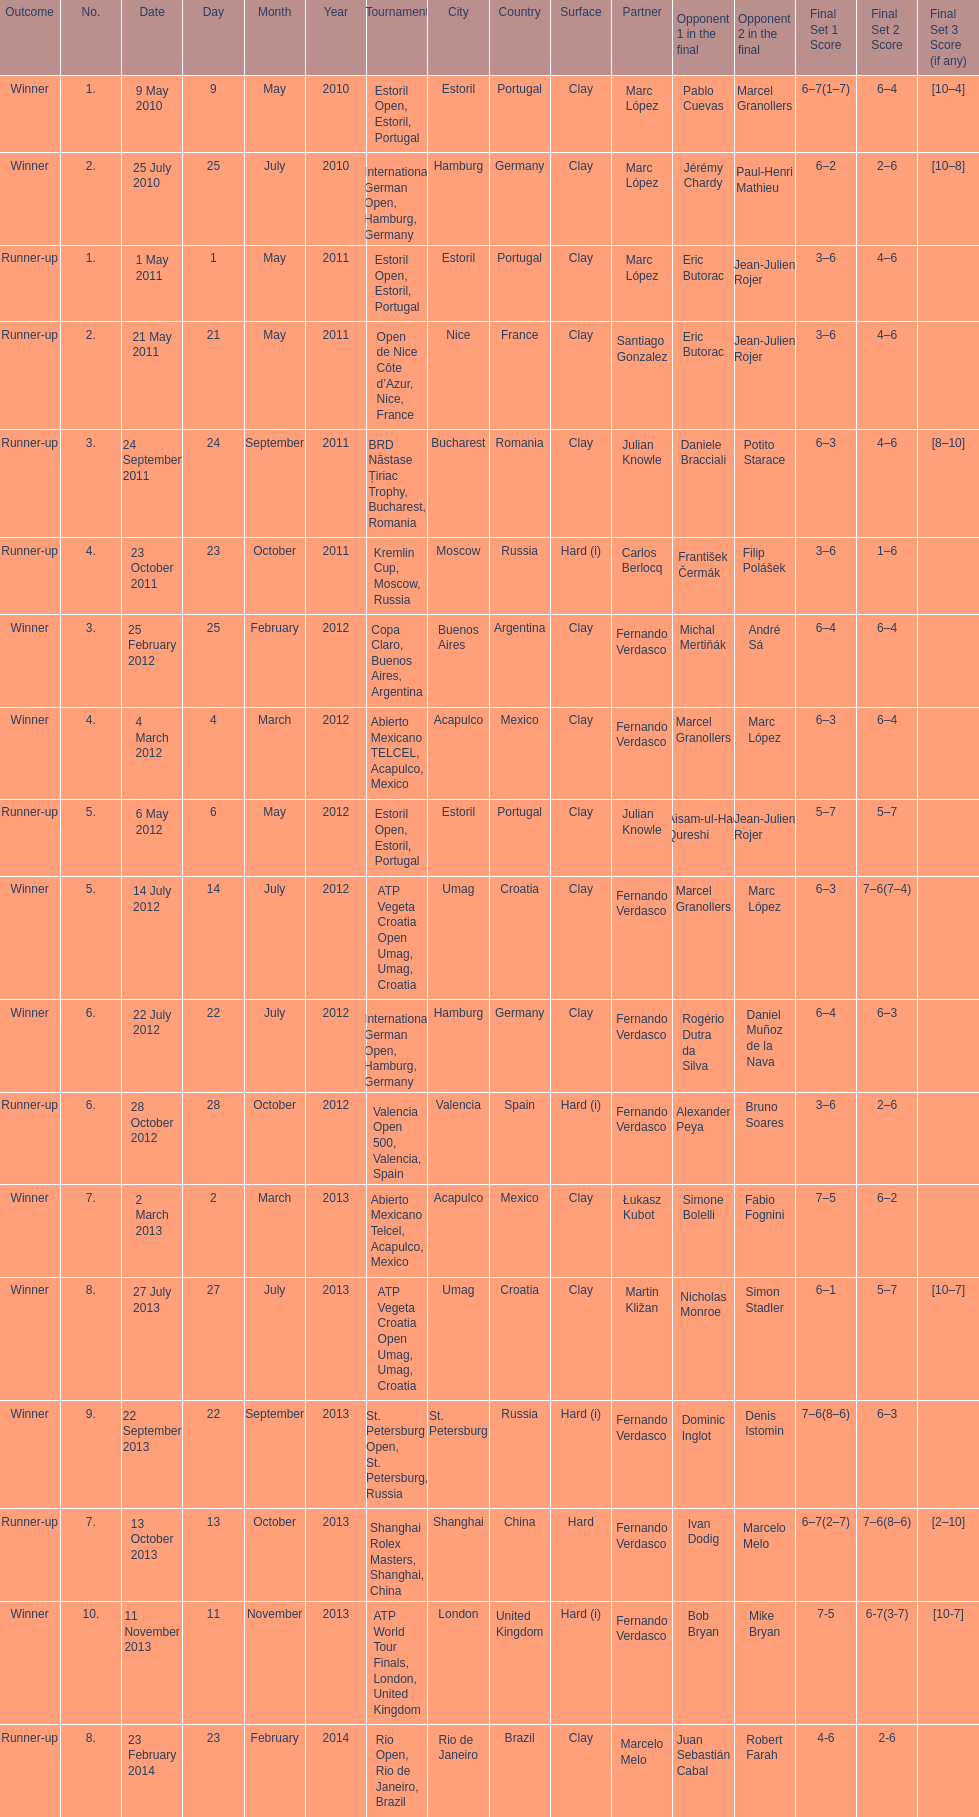What is the number of winning outcomes? 10. 